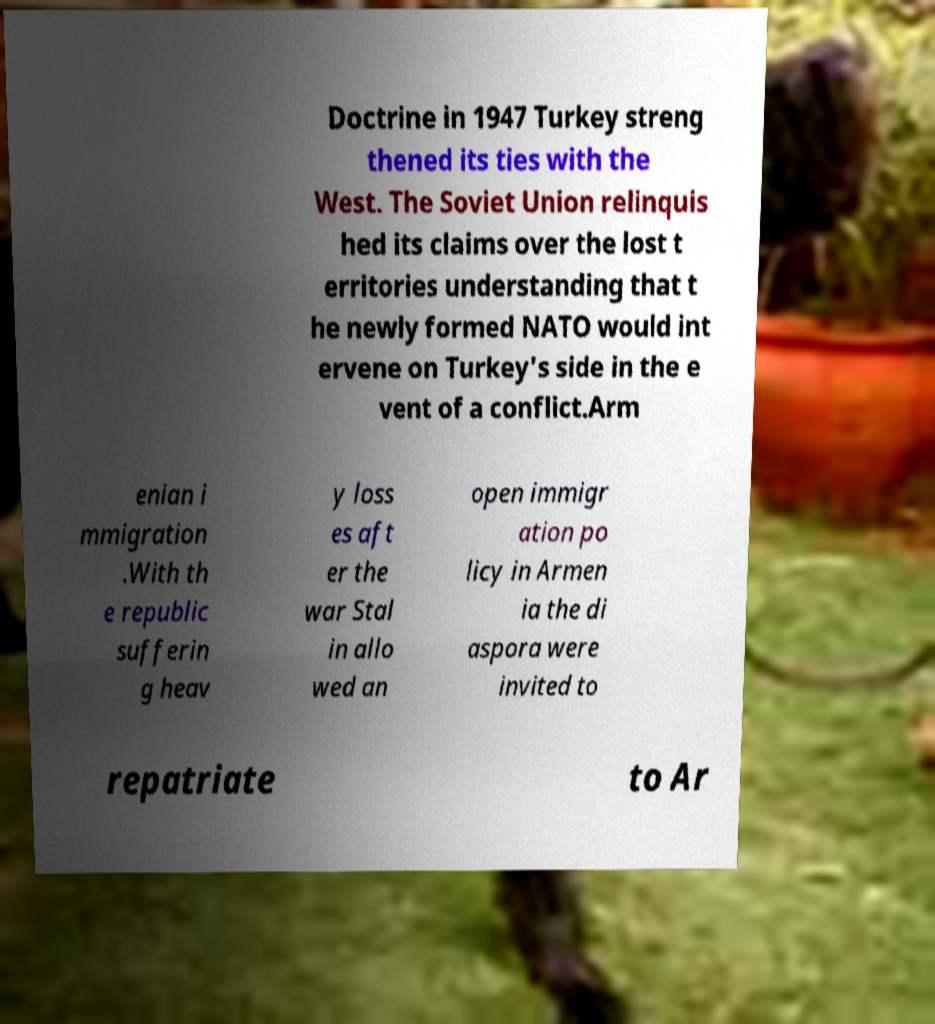I need the written content from this picture converted into text. Can you do that? Doctrine in 1947 Turkey streng thened its ties with the West. The Soviet Union relinquis hed its claims over the lost t erritories understanding that t he newly formed NATO would int ervene on Turkey's side in the e vent of a conflict.Arm enian i mmigration .With th e republic sufferin g heav y loss es aft er the war Stal in allo wed an open immigr ation po licy in Armen ia the di aspora were invited to repatriate to Ar 